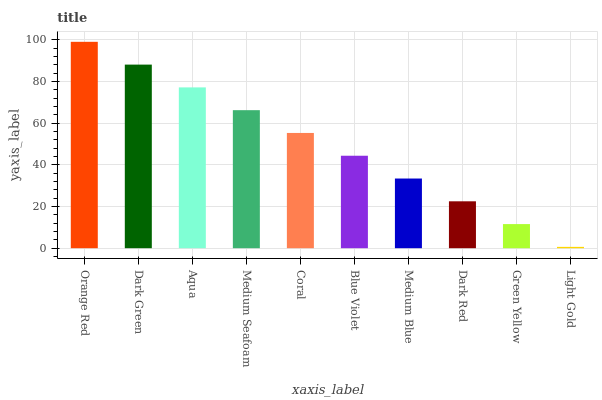Is Light Gold the minimum?
Answer yes or no. Yes. Is Orange Red the maximum?
Answer yes or no. Yes. Is Dark Green the minimum?
Answer yes or no. No. Is Dark Green the maximum?
Answer yes or no. No. Is Orange Red greater than Dark Green?
Answer yes or no. Yes. Is Dark Green less than Orange Red?
Answer yes or no. Yes. Is Dark Green greater than Orange Red?
Answer yes or no. No. Is Orange Red less than Dark Green?
Answer yes or no. No. Is Coral the high median?
Answer yes or no. Yes. Is Blue Violet the low median?
Answer yes or no. Yes. Is Aqua the high median?
Answer yes or no. No. Is Light Gold the low median?
Answer yes or no. No. 